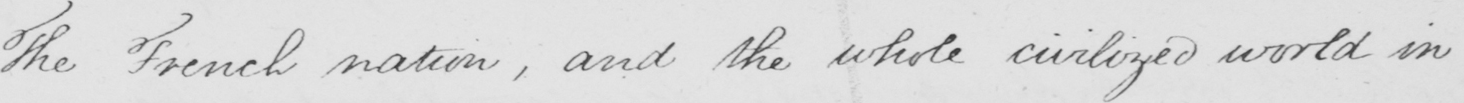What text is written in this handwritten line? The French nation , and the whole civilized world in 